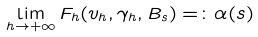Convert formula to latex. <formula><loc_0><loc_0><loc_500><loc_500>\lim _ { h \to + \infty } F _ { h } ( v _ { h } , \gamma _ { h } , B _ { s } ) = \colon \alpha ( s )</formula> 